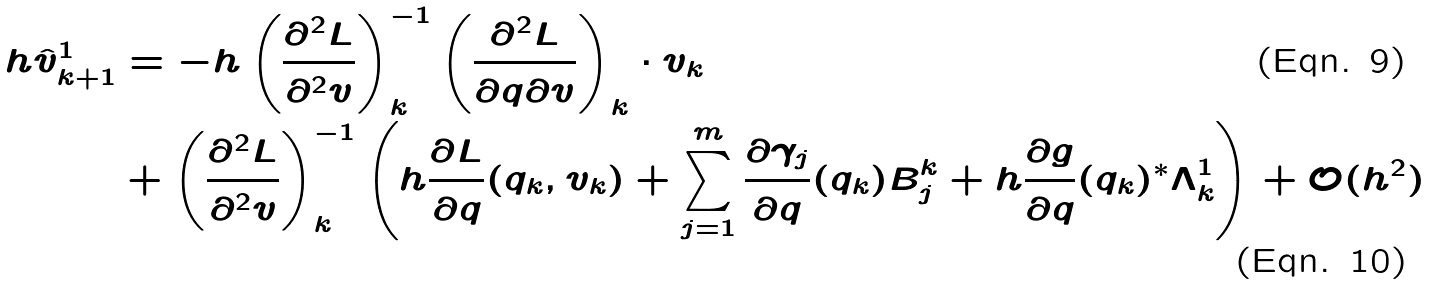Convert formula to latex. <formula><loc_0><loc_0><loc_500><loc_500>h \hat { v } _ { k + 1 } ^ { 1 } & = - h \left ( \frac { \partial ^ { 2 } L } { \partial ^ { 2 } v } \right ) _ { k } ^ { - 1 } \left ( \frac { \partial ^ { 2 } L } { \partial q \partial v } \right ) _ { k } \cdot v _ { k } \\ & + \left ( \frac { \partial ^ { 2 } L } { \partial ^ { 2 } v } \right ) _ { k } ^ { - 1 } \left ( h \frac { \partial L } { \partial q } ( q _ { k } , v _ { k } ) + \sum _ { j = 1 } ^ { m } \frac { \partial \gamma _ { j } } { \partial q } ( q _ { k } ) B _ { j } ^ { k } + h \frac { \partial g } { \partial q } ( q _ { k } ) ^ { * } \Lambda ^ { 1 } _ { k } \right ) + \mathcal { O } ( h ^ { 2 } )</formula> 